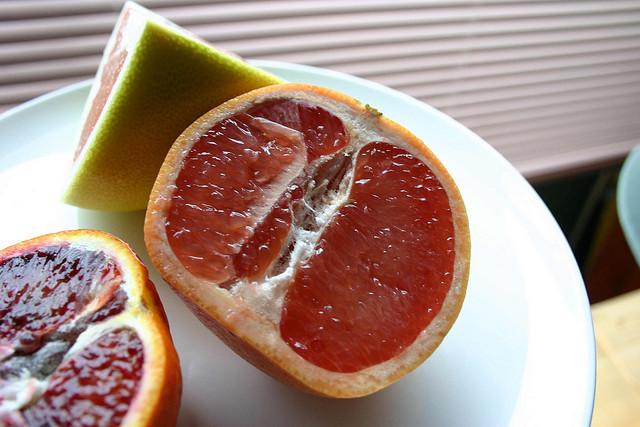What color is the plate?
Be succinct. White. What kind of fruit is on the plate?
Answer briefly. Grapefruit. What meal is this fruit most associated with?
Answer briefly. Breakfast. 